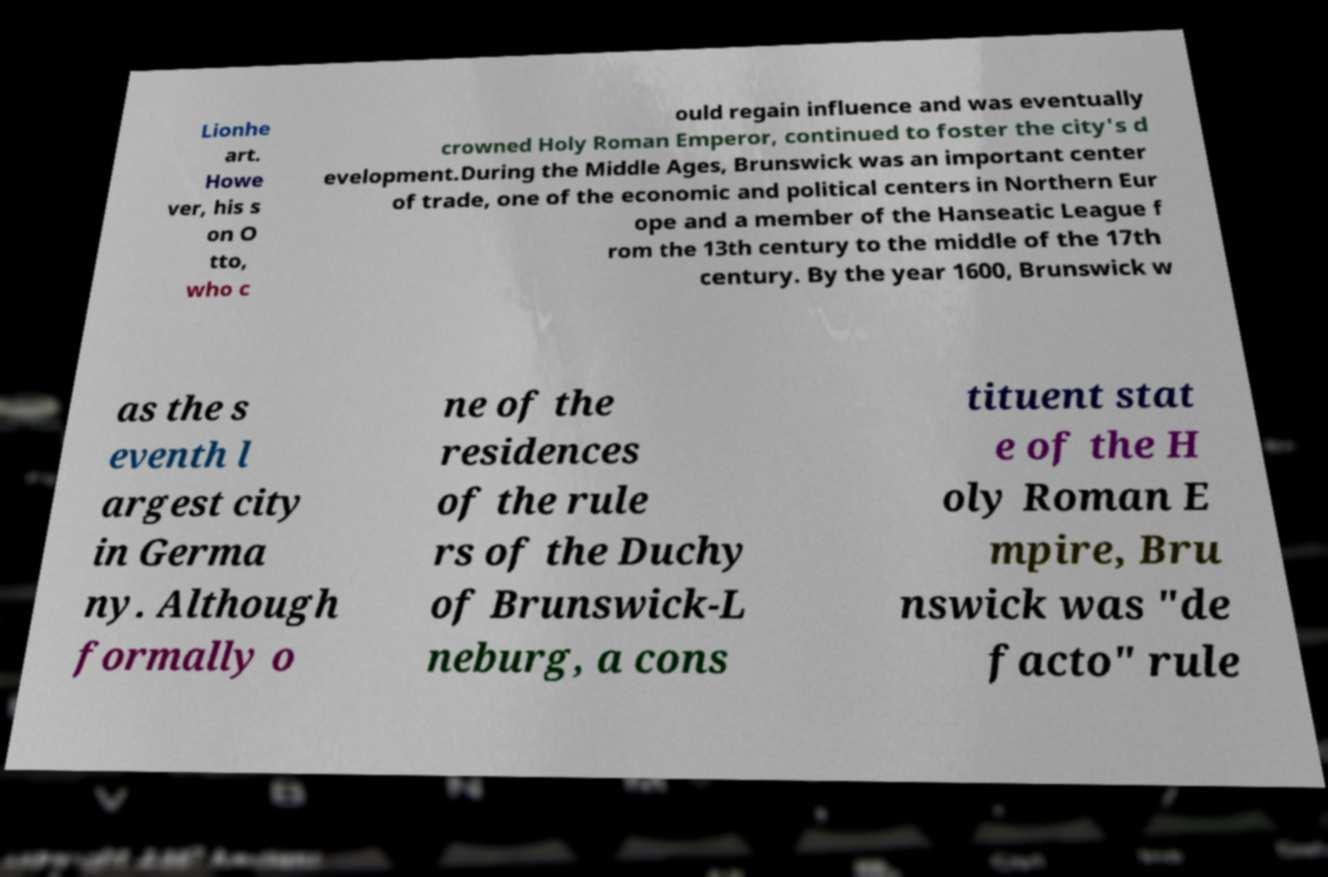Could you extract and type out the text from this image? Lionhe art. Howe ver, his s on O tto, who c ould regain influence and was eventually crowned Holy Roman Emperor, continued to foster the city's d evelopment.During the Middle Ages, Brunswick was an important center of trade, one of the economic and political centers in Northern Eur ope and a member of the Hanseatic League f rom the 13th century to the middle of the 17th century. By the year 1600, Brunswick w as the s eventh l argest city in Germa ny. Although formally o ne of the residences of the rule rs of the Duchy of Brunswick-L neburg, a cons tituent stat e of the H oly Roman E mpire, Bru nswick was "de facto" rule 